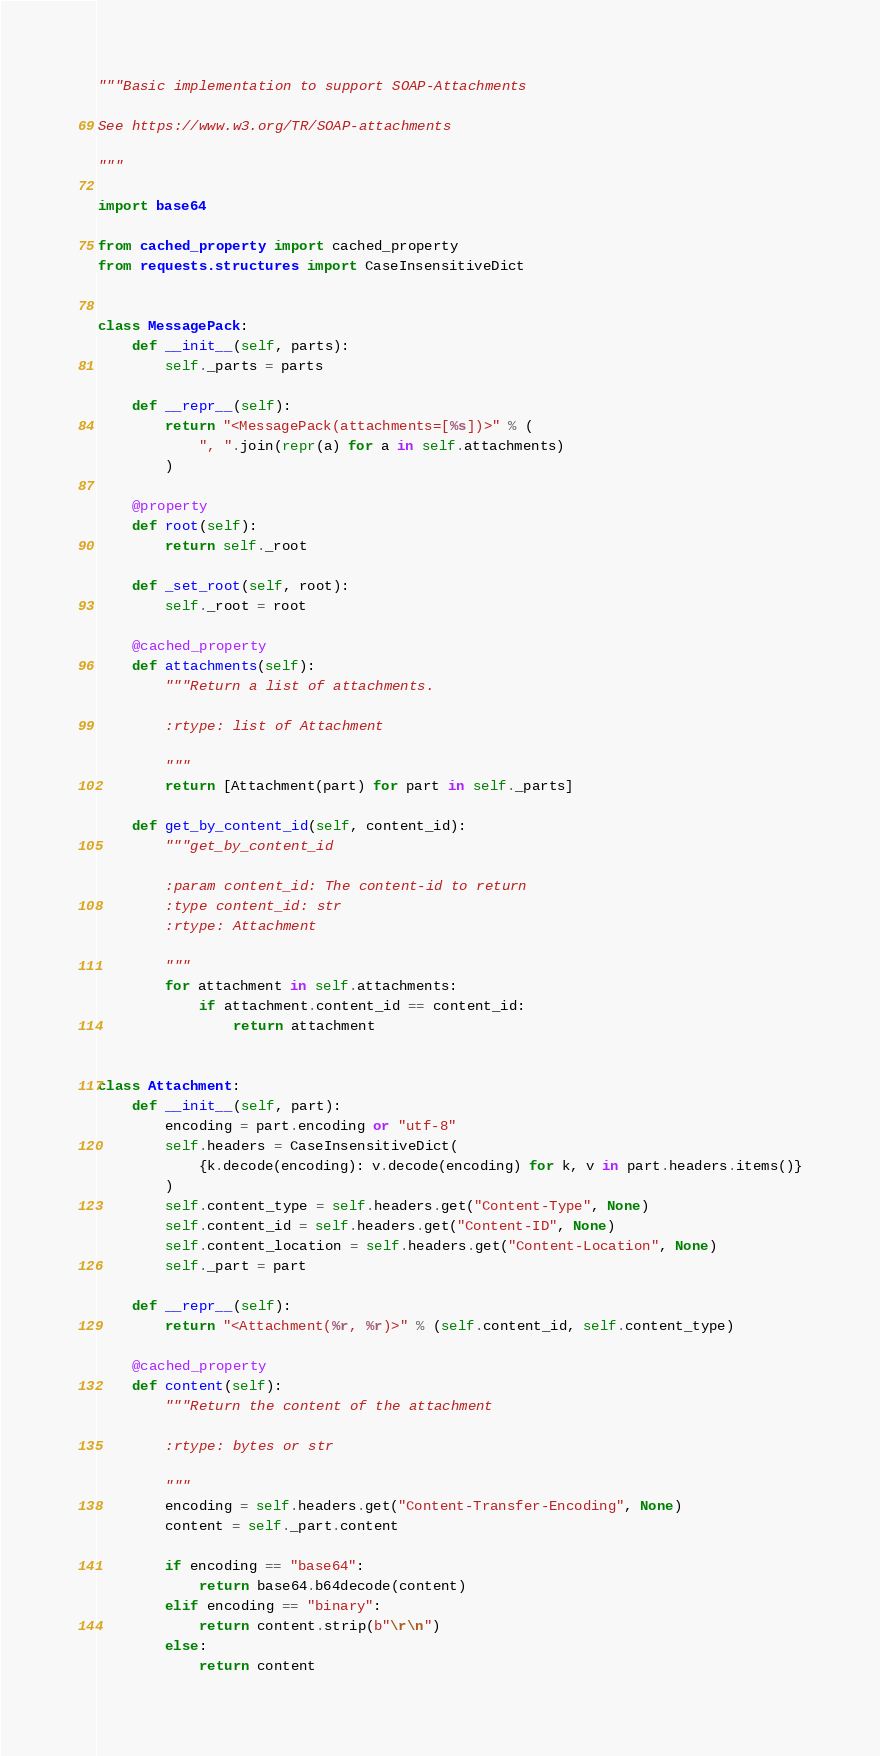<code> <loc_0><loc_0><loc_500><loc_500><_Python_>"""Basic implementation to support SOAP-Attachments

See https://www.w3.org/TR/SOAP-attachments

"""

import base64

from cached_property import cached_property
from requests.structures import CaseInsensitiveDict


class MessagePack:
    def __init__(self, parts):
        self._parts = parts

    def __repr__(self):
        return "<MessagePack(attachments=[%s])>" % (
            ", ".join(repr(a) for a in self.attachments)
        )

    @property
    def root(self):
        return self._root

    def _set_root(self, root):
        self._root = root

    @cached_property
    def attachments(self):
        """Return a list of attachments.

        :rtype: list of Attachment

        """
        return [Attachment(part) for part in self._parts]

    def get_by_content_id(self, content_id):
        """get_by_content_id

        :param content_id: The content-id to return
        :type content_id: str
        :rtype: Attachment

        """
        for attachment in self.attachments:
            if attachment.content_id == content_id:
                return attachment


class Attachment:
    def __init__(self, part):
        encoding = part.encoding or "utf-8"
        self.headers = CaseInsensitiveDict(
            {k.decode(encoding): v.decode(encoding) for k, v in part.headers.items()}
        )
        self.content_type = self.headers.get("Content-Type", None)
        self.content_id = self.headers.get("Content-ID", None)
        self.content_location = self.headers.get("Content-Location", None)
        self._part = part

    def __repr__(self):
        return "<Attachment(%r, %r)>" % (self.content_id, self.content_type)

    @cached_property
    def content(self):
        """Return the content of the attachment

        :rtype: bytes or str

        """
        encoding = self.headers.get("Content-Transfer-Encoding", None)
        content = self._part.content

        if encoding == "base64":
            return base64.b64decode(content)
        elif encoding == "binary":
            return content.strip(b"\r\n")
        else:
            return content
</code> 